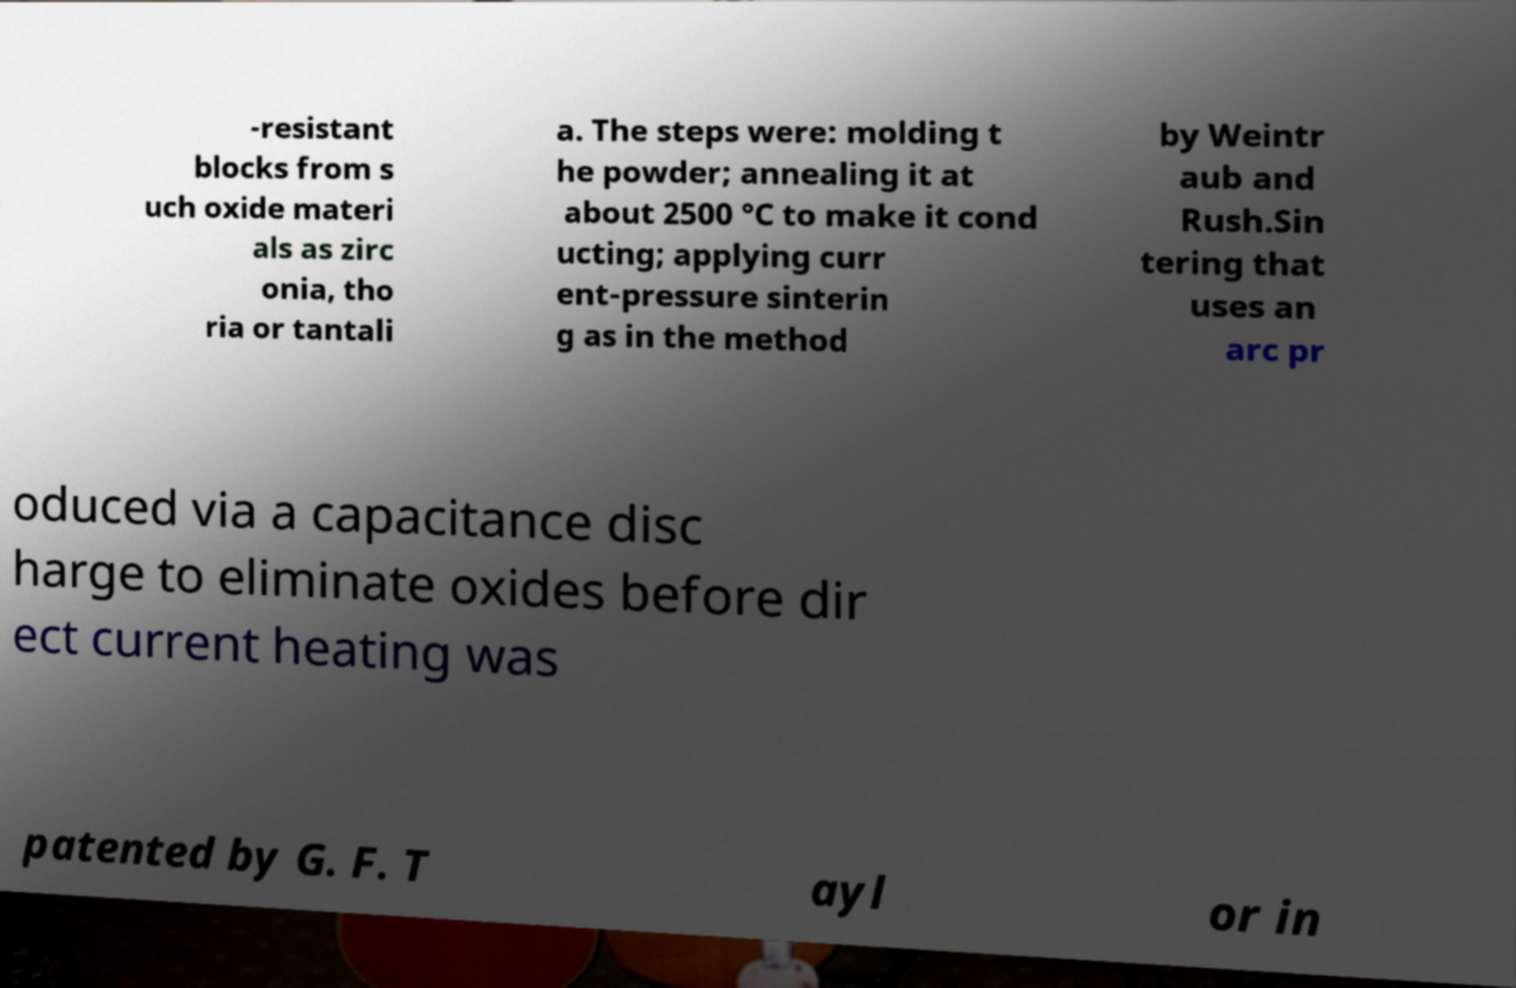For documentation purposes, I need the text within this image transcribed. Could you provide that? -resistant blocks from s uch oxide materi als as zirc onia, tho ria or tantali a. The steps were: molding t he powder; annealing it at about 2500 °C to make it cond ucting; applying curr ent-pressure sinterin g as in the method by Weintr aub and Rush.Sin tering that uses an arc pr oduced via a capacitance disc harge to eliminate oxides before dir ect current heating was patented by G. F. T ayl or in 